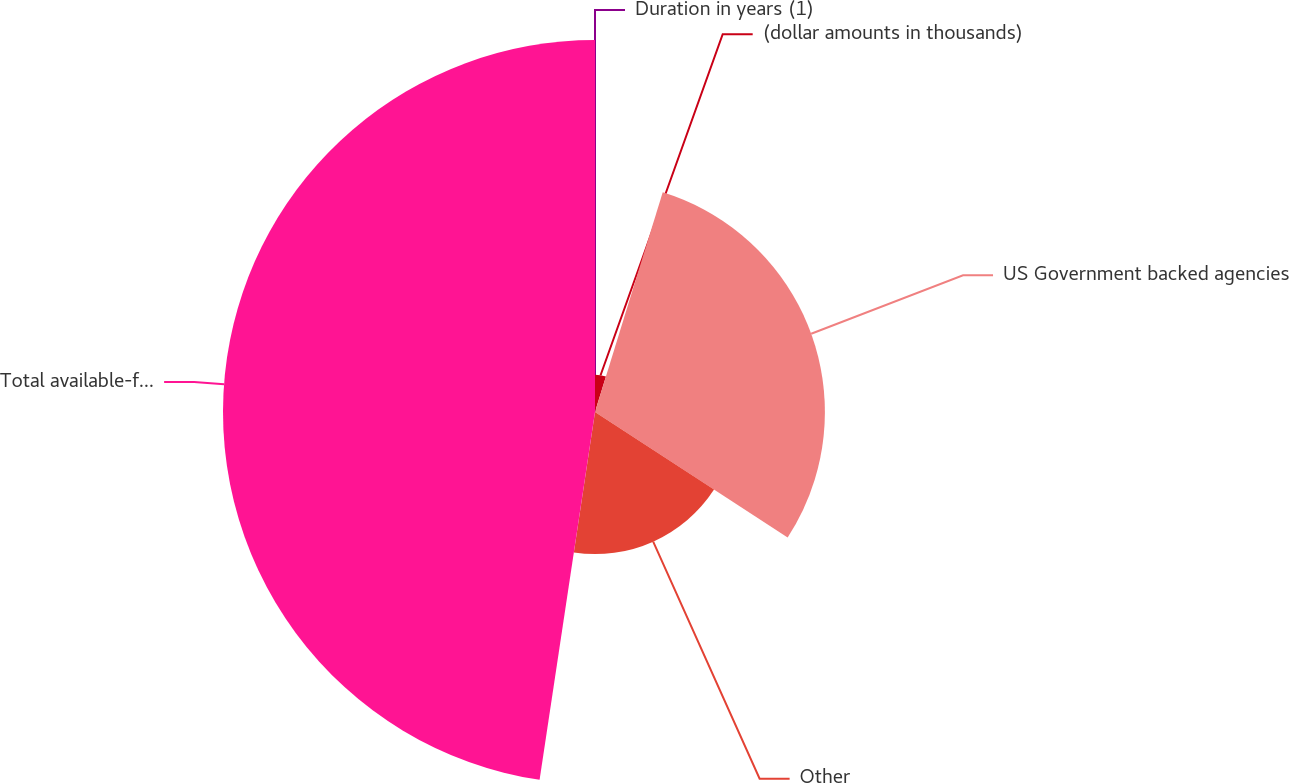Convert chart. <chart><loc_0><loc_0><loc_500><loc_500><pie_chart><fcel>(dollar amounts in thousands)<fcel>US Government backed agencies<fcel>Other<fcel>Total available-for-sale and<fcel>Duration in years (1)<nl><fcel>4.76%<fcel>29.43%<fcel>18.19%<fcel>47.62%<fcel>0.0%<nl></chart> 